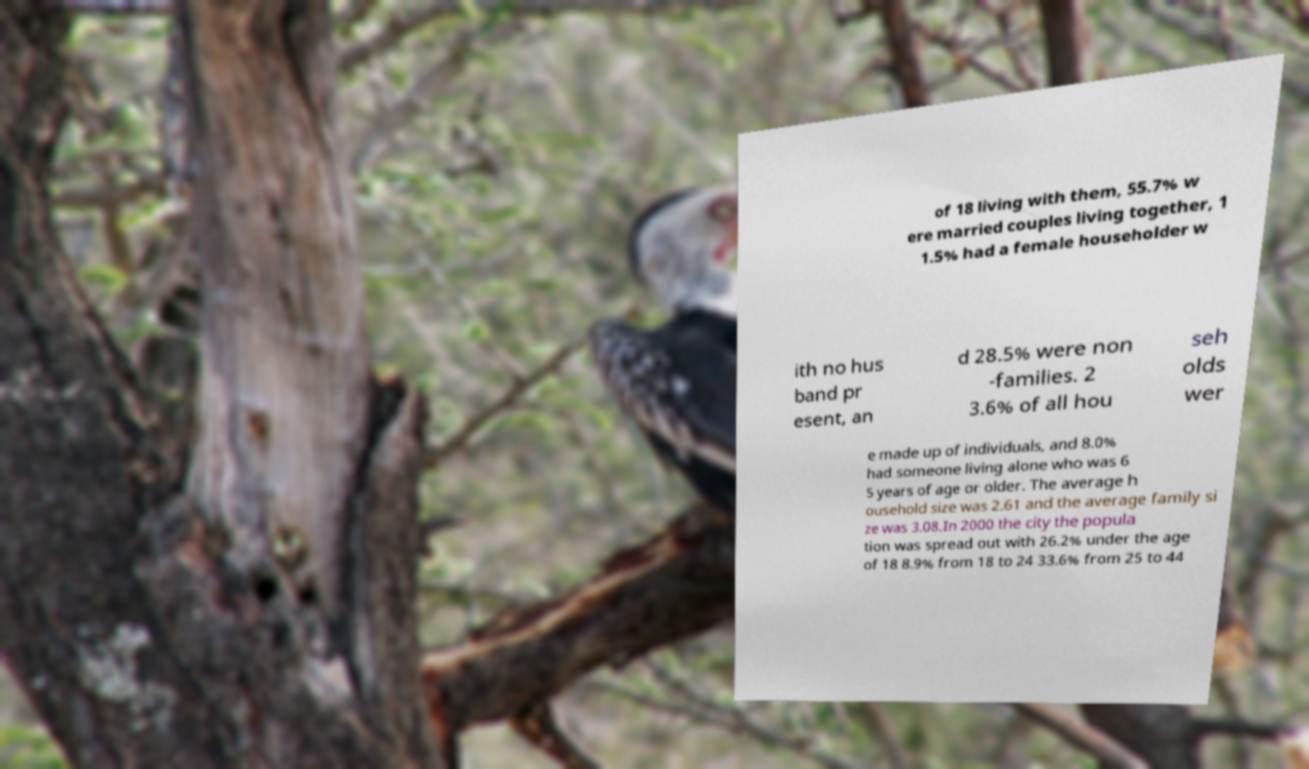Can you accurately transcribe the text from the provided image for me? of 18 living with them, 55.7% w ere married couples living together, 1 1.5% had a female householder w ith no hus band pr esent, an d 28.5% were non -families. 2 3.6% of all hou seh olds wer e made up of individuals, and 8.0% had someone living alone who was 6 5 years of age or older. The average h ousehold size was 2.61 and the average family si ze was 3.08.In 2000 the city the popula tion was spread out with 26.2% under the age of 18 8.9% from 18 to 24 33.6% from 25 to 44 